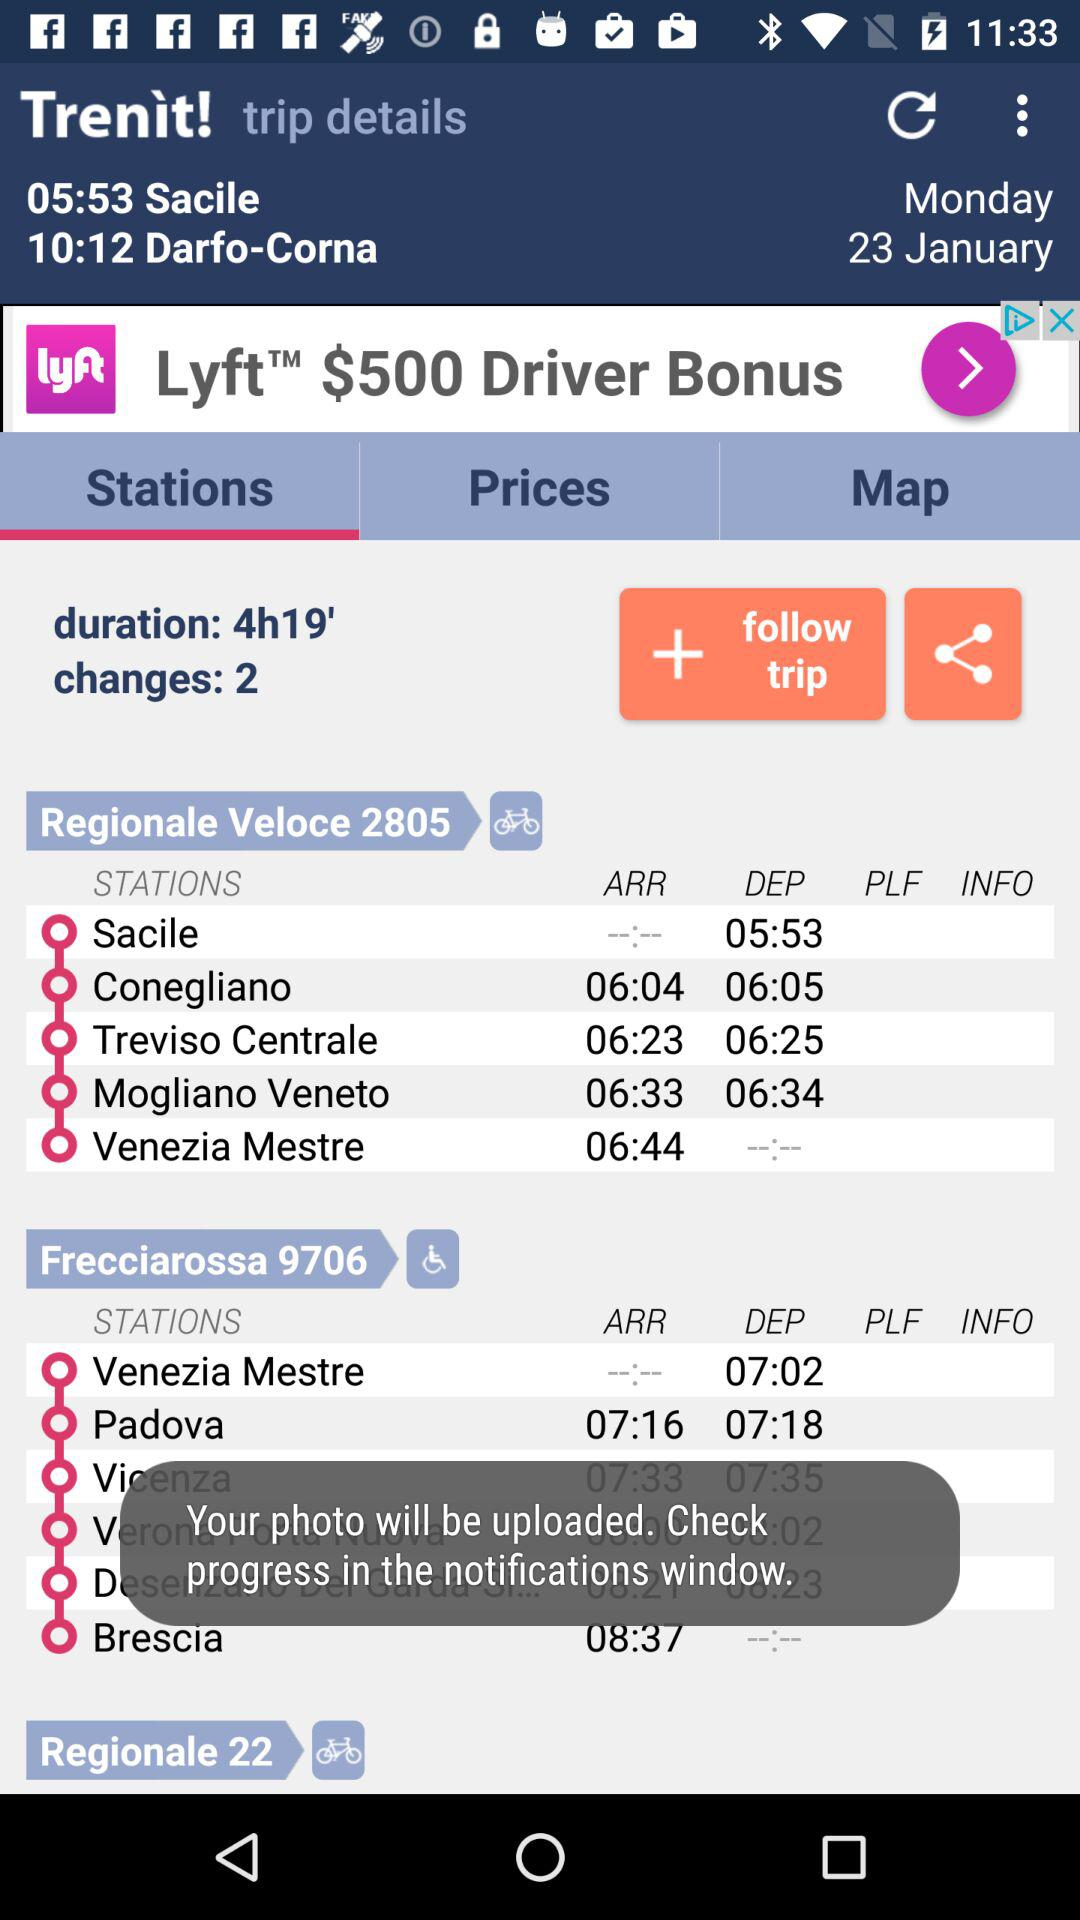What is the number of changes? The number of changes is 2. 